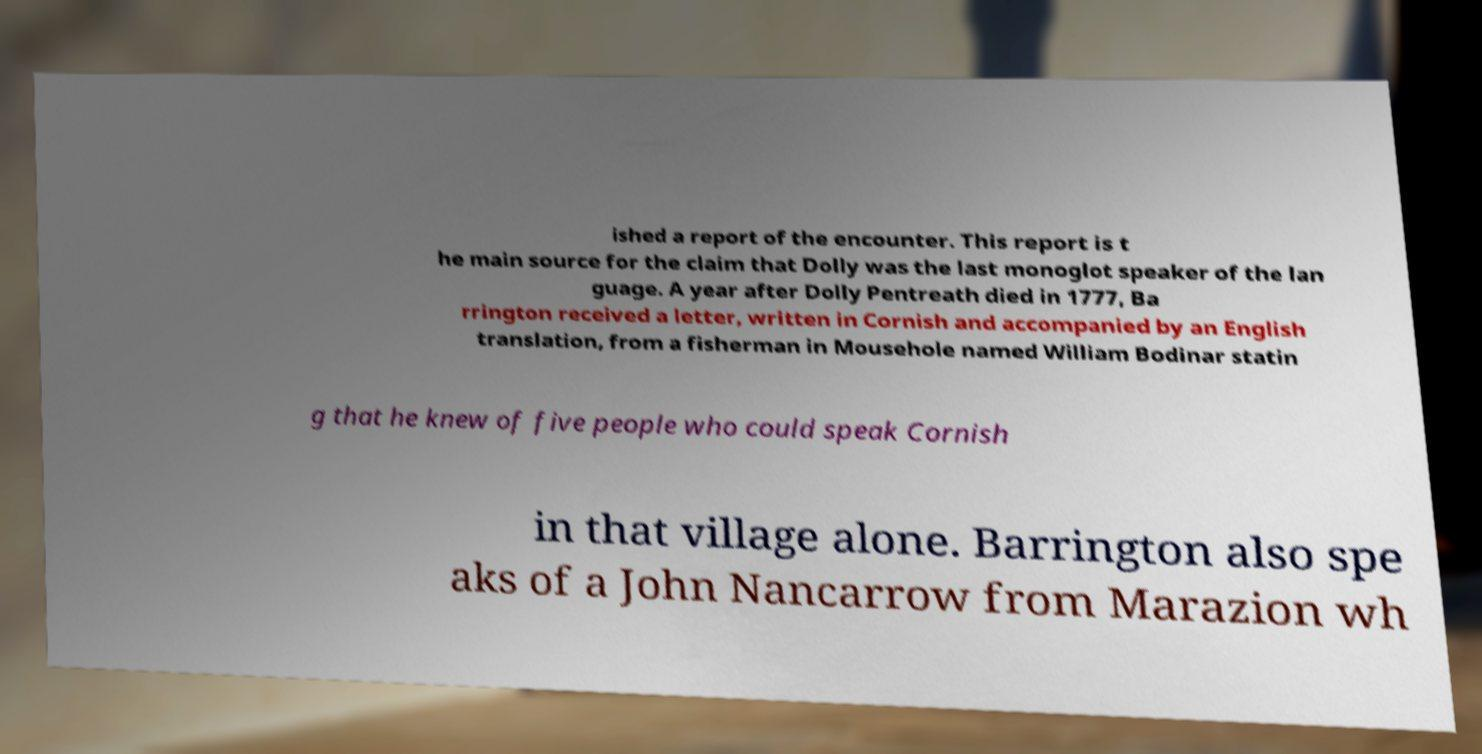There's text embedded in this image that I need extracted. Can you transcribe it verbatim? ished a report of the encounter. This report is t he main source for the claim that Dolly was the last monoglot speaker of the lan guage. A year after Dolly Pentreath died in 1777, Ba rrington received a letter, written in Cornish and accompanied by an English translation, from a fisherman in Mousehole named William Bodinar statin g that he knew of five people who could speak Cornish in that village alone. Barrington also spe aks of a John Nancarrow from Marazion wh 